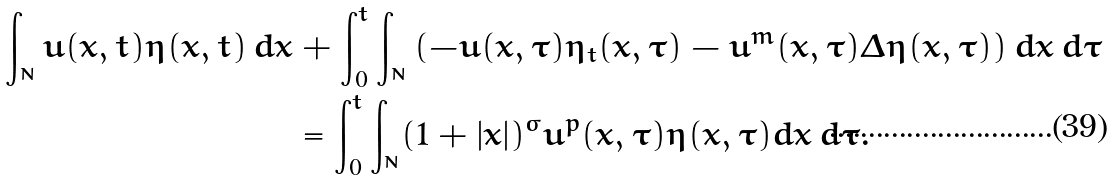<formula> <loc_0><loc_0><loc_500><loc_500>\int _ { \real ^ { N } } u ( x , t ) \eta ( x , t ) \, d x & + \int _ { 0 } ^ { t } \int _ { \real ^ { N } } \left ( - u ( x , \tau ) \eta _ { t } ( x , \tau ) - u ^ { m } ( x , \tau ) \Delta \eta ( x , \tau ) \right ) d x \, d \tau \\ & = \int _ { 0 } ^ { t } \int _ { \real ^ { N } } ( 1 + | x | ) ^ { \sigma } u ^ { p } ( x , \tau ) \eta ( x , \tau ) d x \, d \tau .</formula> 